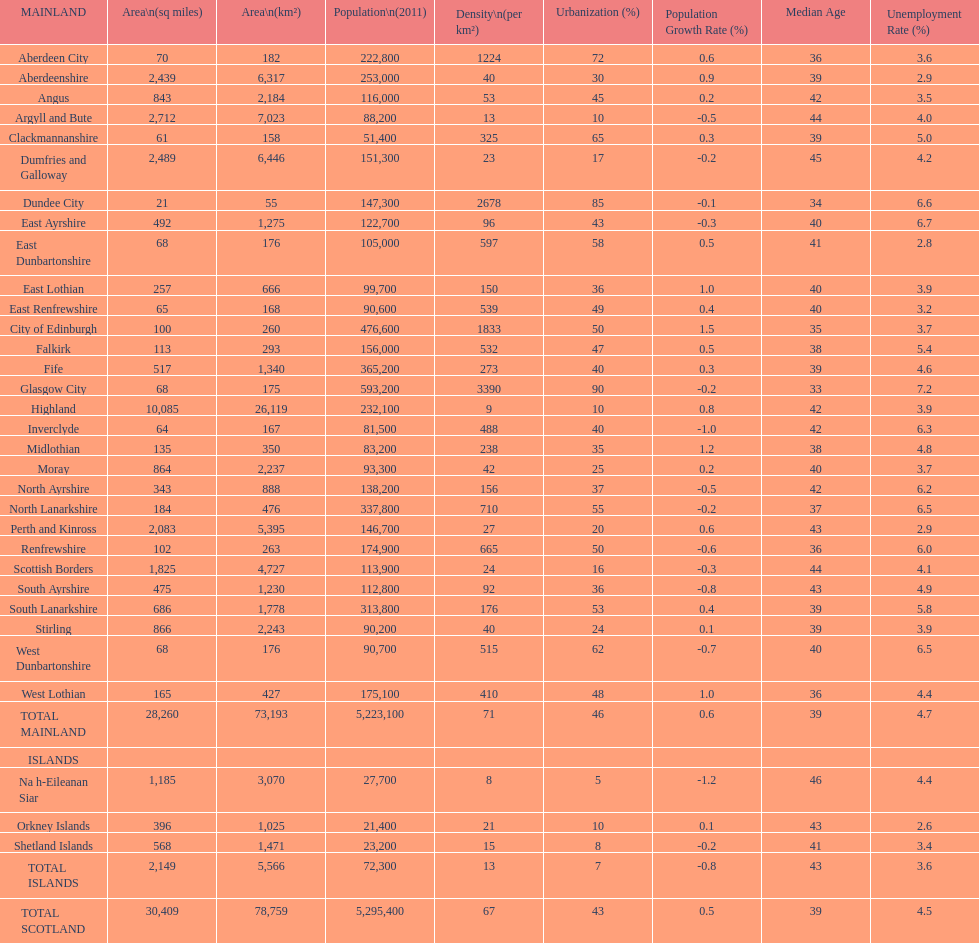What is the total area of east lothian, angus, and dundee city? 1121. 